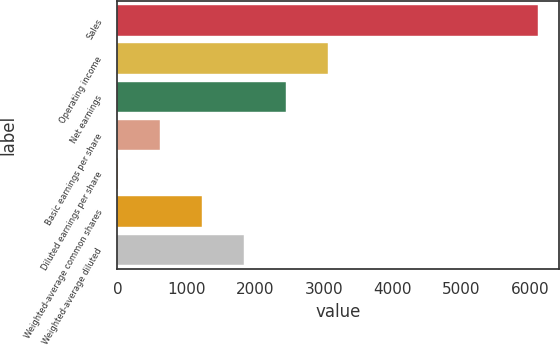<chart> <loc_0><loc_0><loc_500><loc_500><bar_chart><fcel>Sales<fcel>Operating income<fcel>Net earnings<fcel>Basic earnings per share<fcel>Diluted earnings per share<fcel>Weighted-average common shares<fcel>Weighted-average diluted<nl><fcel>6106<fcel>3054.09<fcel>2443.7<fcel>612.53<fcel>2.14<fcel>1222.92<fcel>1833.31<nl></chart> 